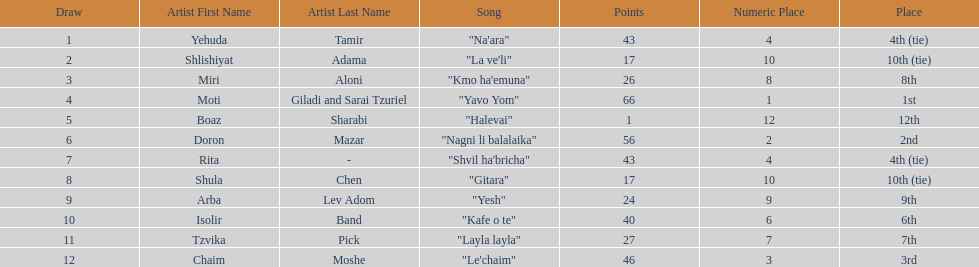Which artist had almost no points? Boaz Sharabi. 